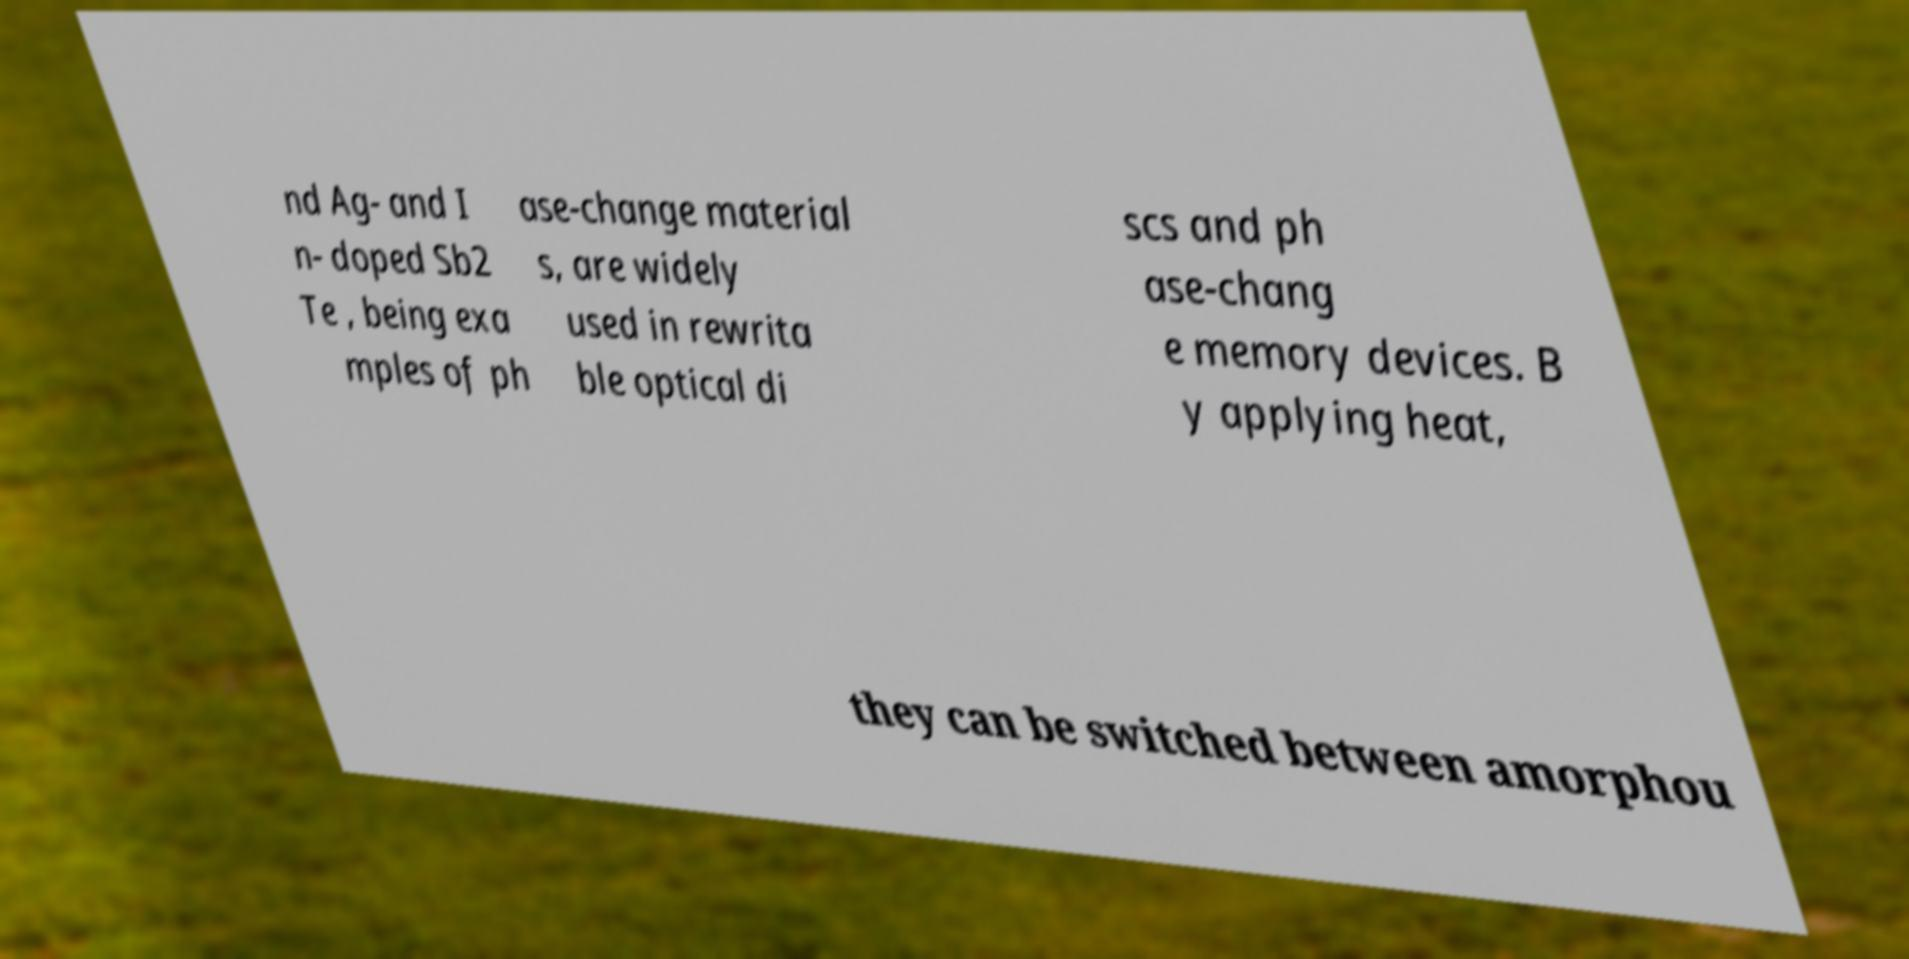Can you read and provide the text displayed in the image?This photo seems to have some interesting text. Can you extract and type it out for me? nd Ag- and I n- doped Sb2 Te , being exa mples of ph ase-change material s, are widely used in rewrita ble optical di scs and ph ase-chang e memory devices. B y applying heat, they can be switched between amorphou 